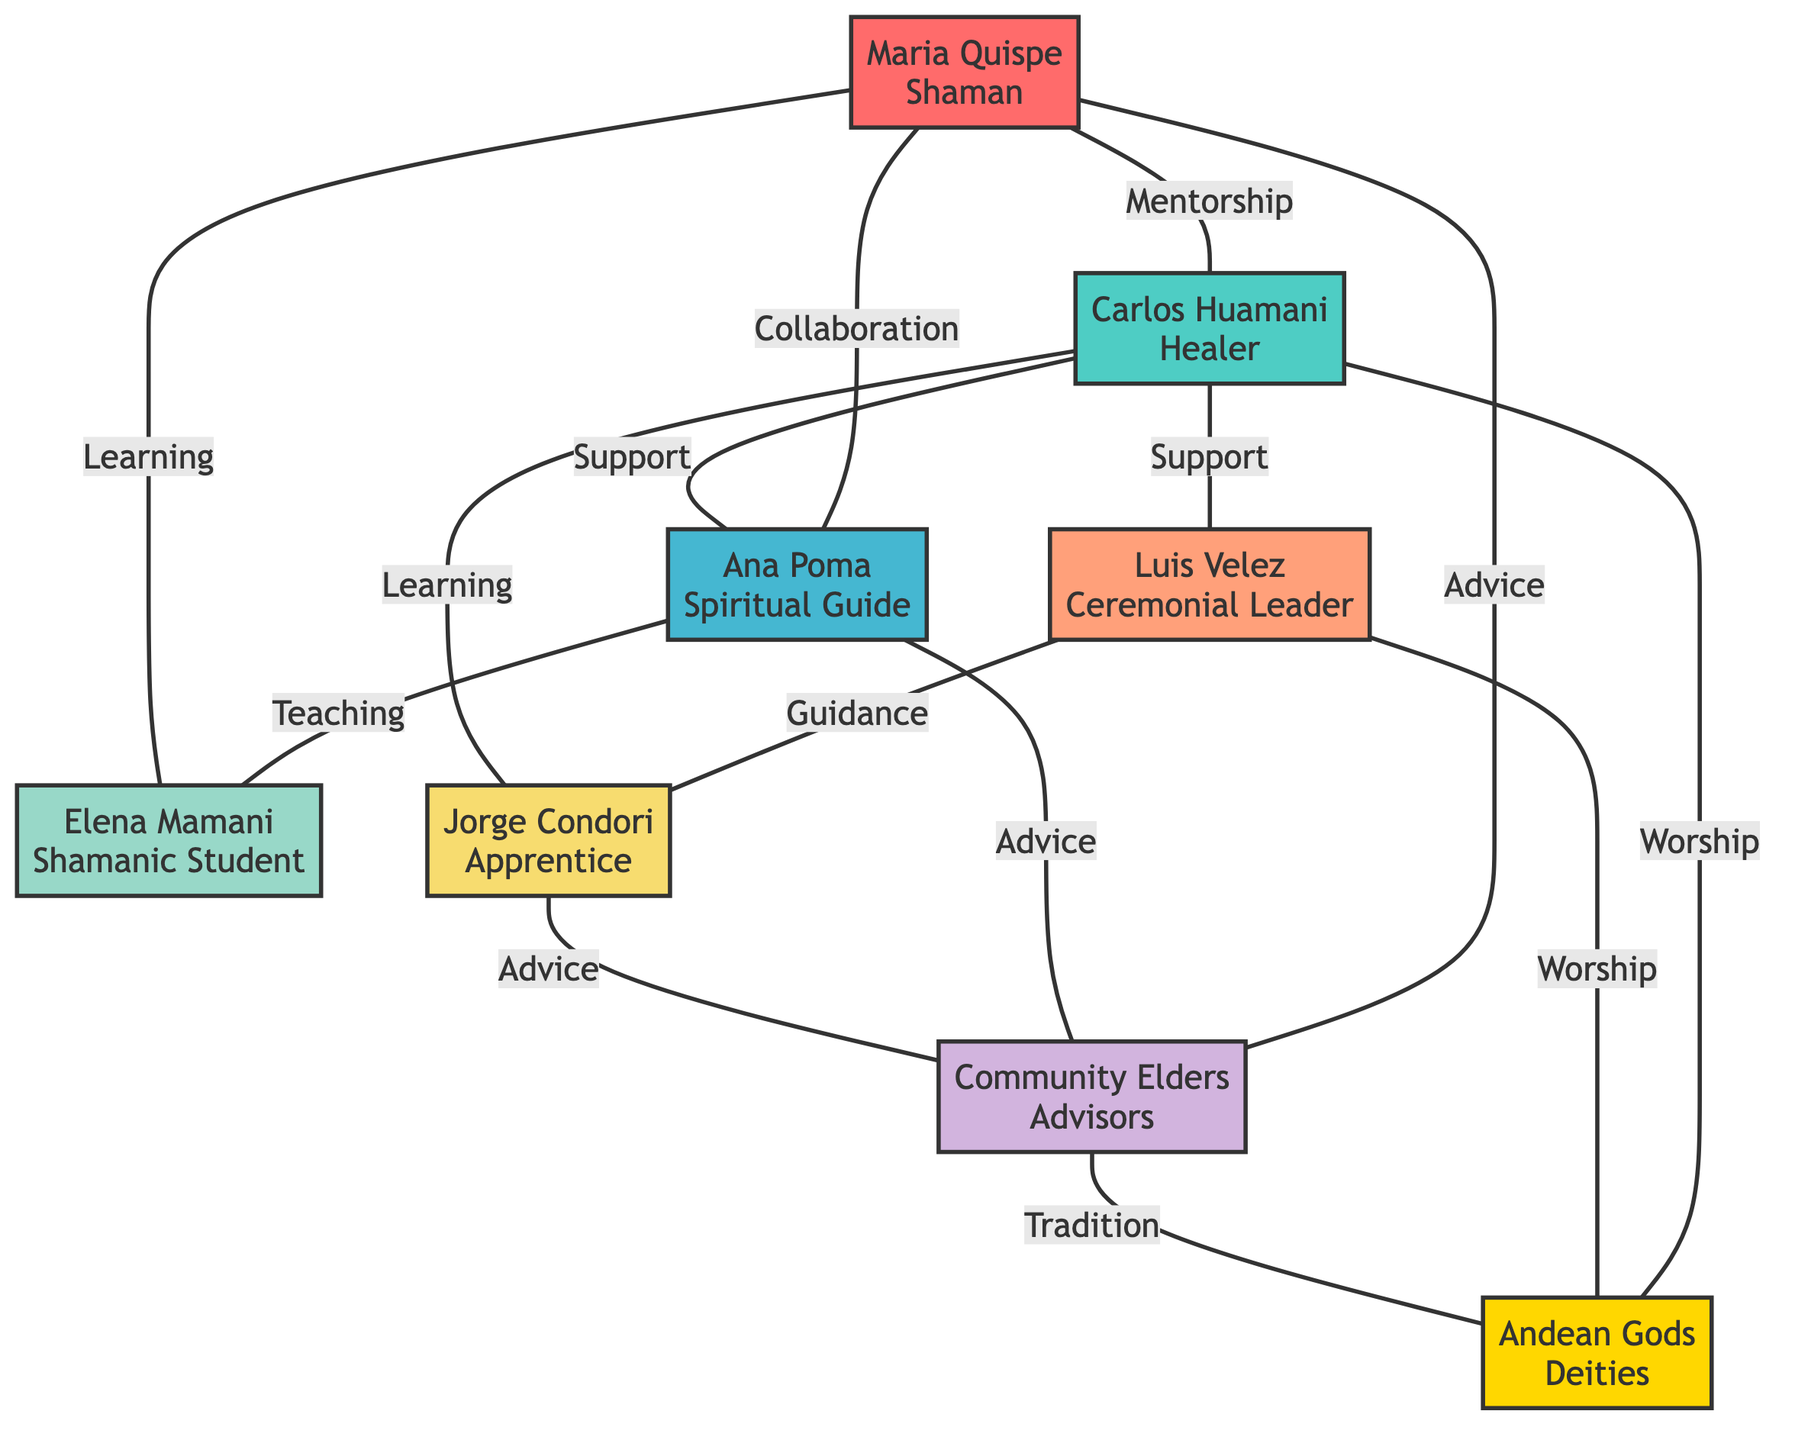What is the role of Maria Quispe? The diagram indicates that Maria Quispe is labeled as a "Shaman" in her node information.
Answer: Shaman Who does Carlos Huamani support? The edge between Carlos Huamani and Luis Velez shows a "Support" relationship, indicating that Carlos Huamani supports Luis Velez.
Answer: Luis Velez How many total nodes are present in the diagram? By counting the nodes listed, there are 8 distinct nodes in total (Maria Quispe, Carlos Huamani, Ana Poma, Luis Velez, Elena Mamani, Jorge Condori, Community Elders, Andean Gods).
Answer: 8 What kind of relationship exists between Ana Poma and Elena Mamani? There is an edge from Ana Poma to Elena Mamani labeled "Teaching," indicating that Ana Poma teaches Elena Mamani.
Answer: Teaching Which two individuals are connected through the relationship of "Mentorship"? The edge between Maria Quispe and Carlos Huamani is labeled "Mentorship," showing that Maria Quispe mentors Carlos Huamani.
Answer: Maria Quispe and Carlos Huamani What is the connection between Jorge Condori and Community Elders? Jorge Condori has an edge connecting him to Community Elders, described by the relationship "Advice," which signifies that Jorge Condori receives advice from Community Elders.
Answer: Advice How many relationships involve worshiping Andean Gods? There are three edges labeled "Worship": one from Carlos Huamani and one from Luis Velez, plus one from Community Elders, indicating a total of three relationships involving worshiping Andean Gods.
Answer: 3 Who learns from who in the case of Jorge Condori and Carlos Huamani? The edge from Jorge Condori to Carlos Huamani is labeled "Learning," indicating that Jorge Condori learns from Carlos Huamani.
Answer: Carlos Huamani Which leader has a direct connection with both the Community Elders and the Andean Gods? Maria Quispe has edges to both Community Elders (labeled "Advice") and Andean Gods (involving "Worship"), indicating her direct connections to both.
Answer: Maria Quispe 